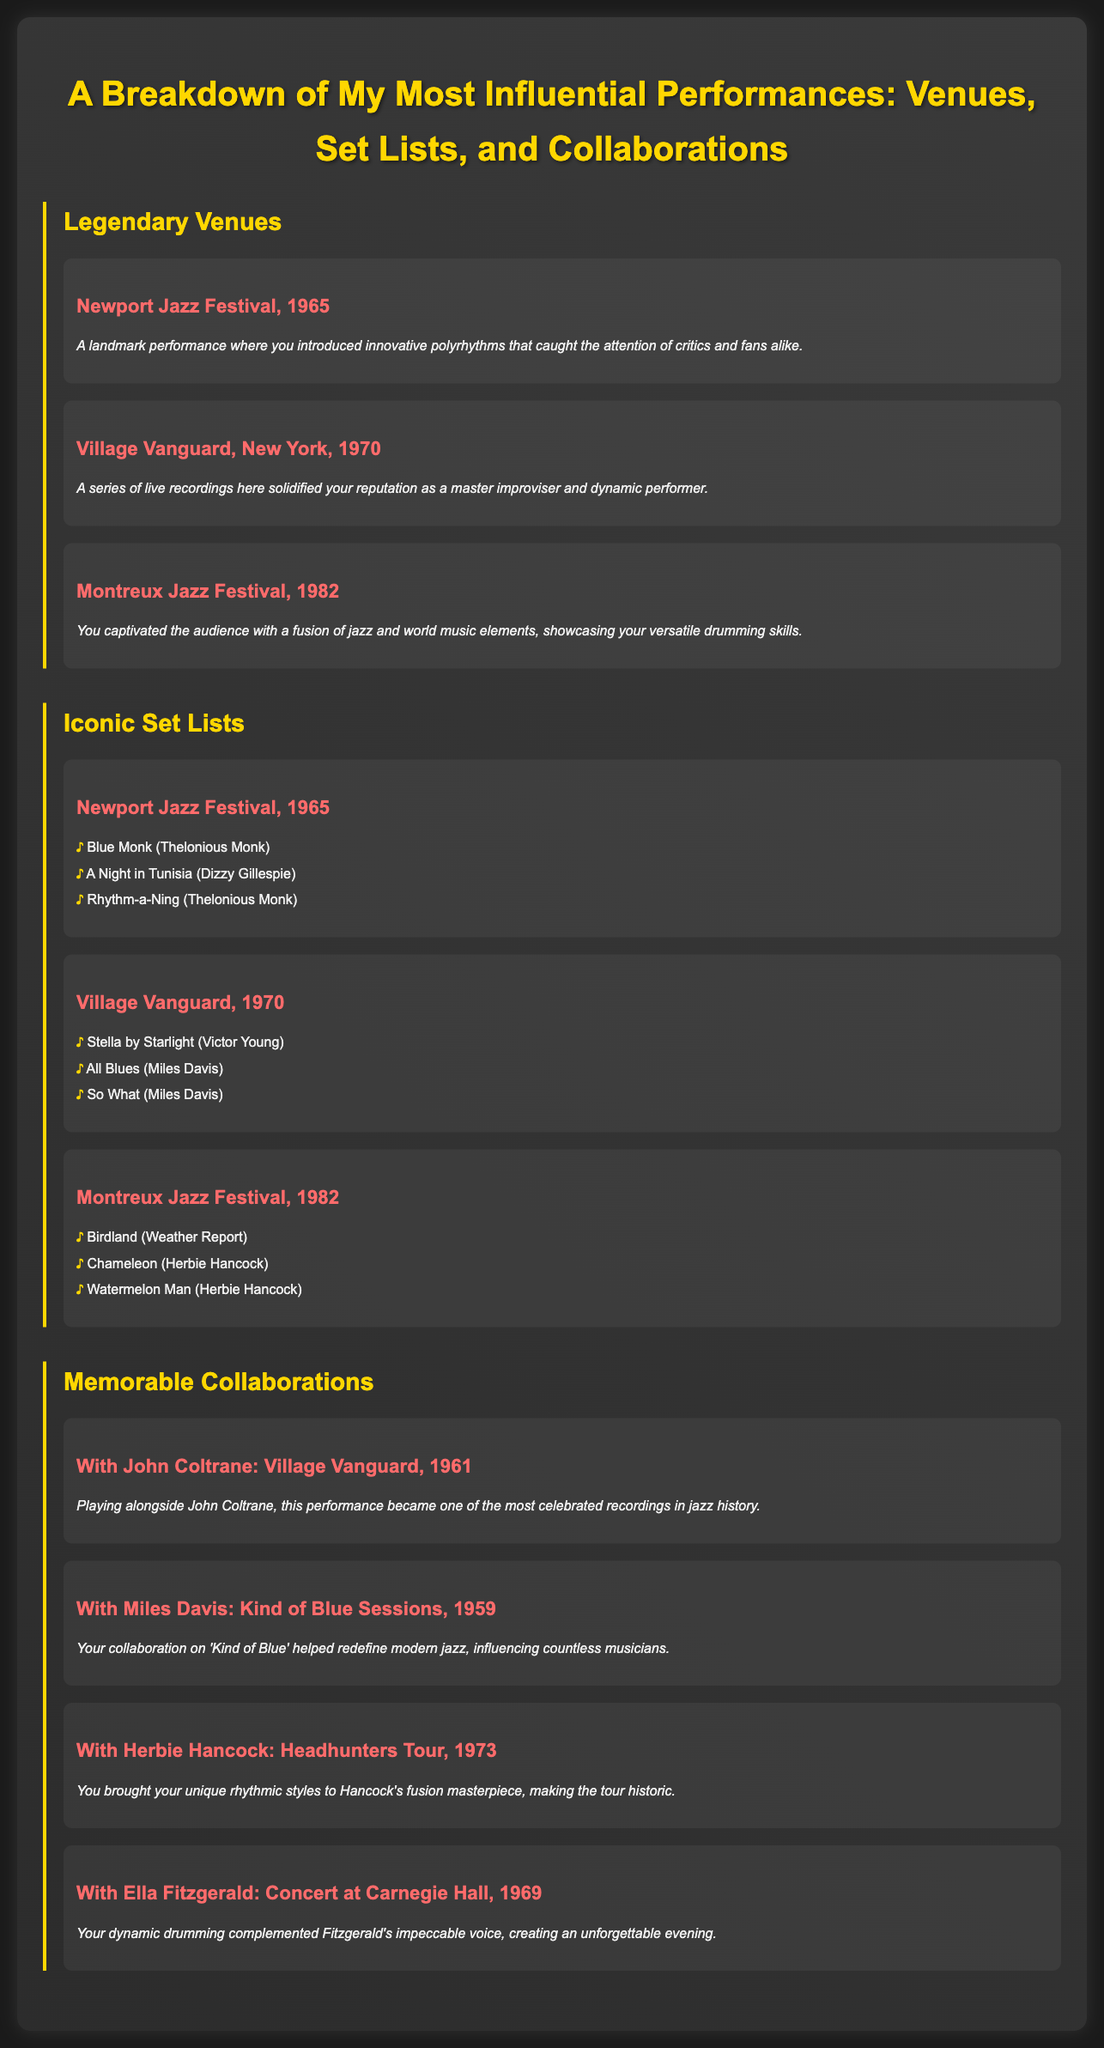What year did the Newport Jazz Festival performance take place? The document states that the Newport Jazz Festival performance occurred in 1965.
Answer: 1965 Which venue hosted the series of live recordings that solidified the reputation? The document mentions that the series of live recordings solidified the reputation at the Village Vanguard.
Answer: Village Vanguard What was one of the iconic set list pieces performed at Montreux Jazz Festival? The document lists "Birdland" as one of the pieces performed at the Montreux Jazz Festival.
Answer: Birdland Who did the legendary collaboration at the Village Vanguard in 1961? The document states that John Coltrane was the collaborator at the Village Vanguard in 1961.
Answer: John Coltrane What type of music elements were showcased at the Montreux Jazz Festival performance? The performance showcased a fusion of jazz and world music elements, according to the document.
Answer: Jazz and world music elements Which year did the Concert at Carnegie Hall with Ella Fitzgerald take place? The document indicates that the Concert at Carnegie Hall with Ella Fitzgerald occurred in 1969.
Answer: 1969 How many memorable collaborations are listed in the document? The document features a total of four memorable collaborations.
Answer: Four What was unique about the drumming style showcased at the Headhunters Tour in 1973? The document highlights that the unique rhythmic styles were brought to Hancock's fusion masterpiece during the tour.
Answer: Unique rhythmic styles What is the main theme of the document? The main theme is a breakdown of influential performances, including venues, set lists, and collaborations.
Answer: Influential performances 